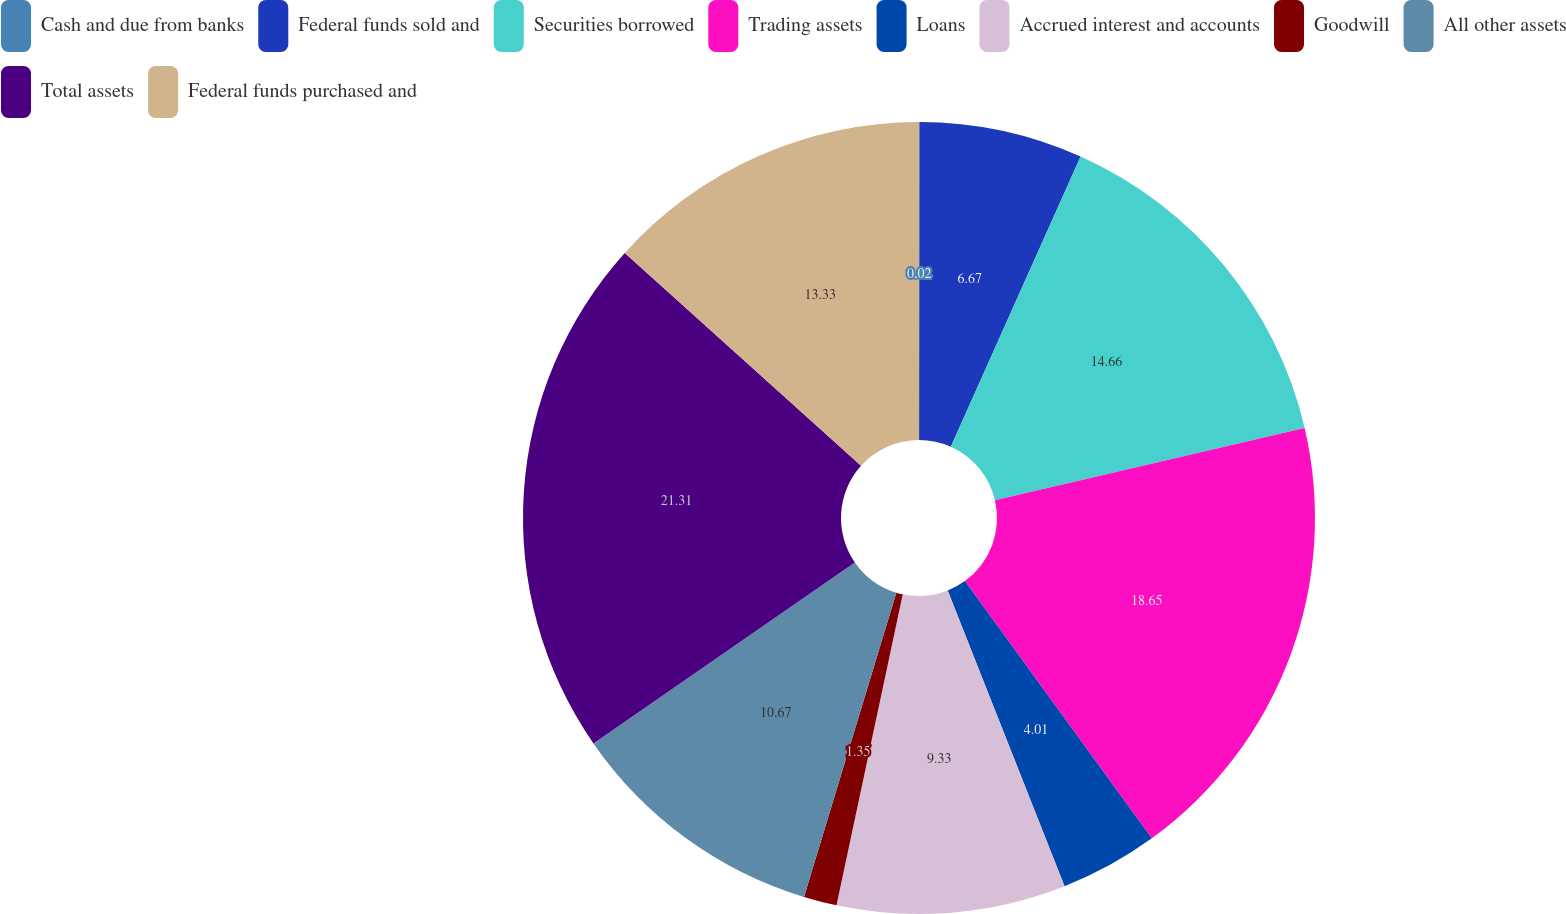<chart> <loc_0><loc_0><loc_500><loc_500><pie_chart><fcel>Cash and due from banks<fcel>Federal funds sold and<fcel>Securities borrowed<fcel>Trading assets<fcel>Loans<fcel>Accrued interest and accounts<fcel>Goodwill<fcel>All other assets<fcel>Total assets<fcel>Federal funds purchased and<nl><fcel>0.02%<fcel>6.67%<fcel>14.66%<fcel>18.65%<fcel>4.01%<fcel>9.33%<fcel>1.35%<fcel>10.67%<fcel>21.31%<fcel>13.33%<nl></chart> 